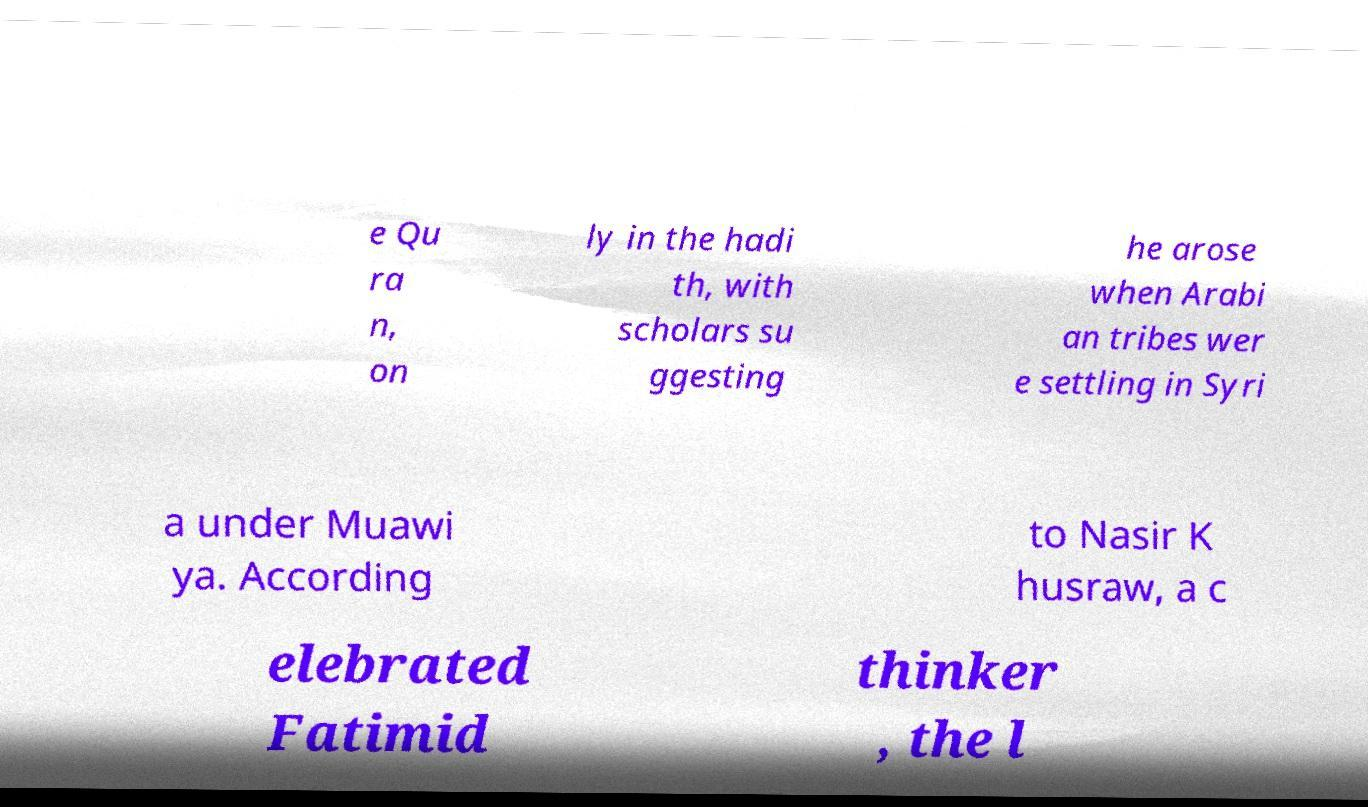Can you read and provide the text displayed in the image?This photo seems to have some interesting text. Can you extract and type it out for me? e Qu ra n, on ly in the hadi th, with scholars su ggesting he arose when Arabi an tribes wer e settling in Syri a under Muawi ya. According to Nasir K husraw, a c elebrated Fatimid thinker , the l 